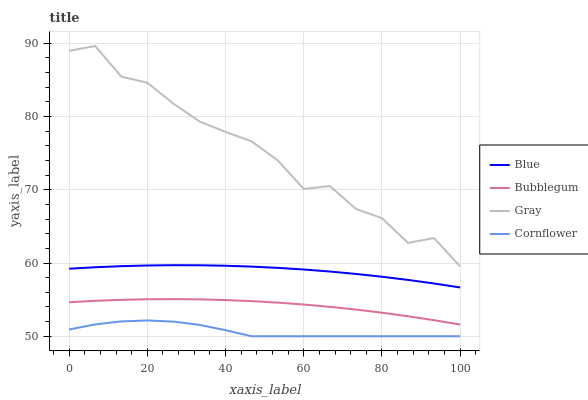Does Cornflower have the minimum area under the curve?
Answer yes or no. Yes. Does Gray have the maximum area under the curve?
Answer yes or no. Yes. Does Bubblegum have the minimum area under the curve?
Answer yes or no. No. Does Bubblegum have the maximum area under the curve?
Answer yes or no. No. Is Blue the smoothest?
Answer yes or no. Yes. Is Gray the roughest?
Answer yes or no. Yes. Is Bubblegum the smoothest?
Answer yes or no. No. Is Bubblegum the roughest?
Answer yes or no. No. Does Cornflower have the lowest value?
Answer yes or no. Yes. Does Bubblegum have the lowest value?
Answer yes or no. No. Does Gray have the highest value?
Answer yes or no. Yes. Does Bubblegum have the highest value?
Answer yes or no. No. Is Bubblegum less than Blue?
Answer yes or no. Yes. Is Gray greater than Blue?
Answer yes or no. Yes. Does Bubblegum intersect Blue?
Answer yes or no. No. 